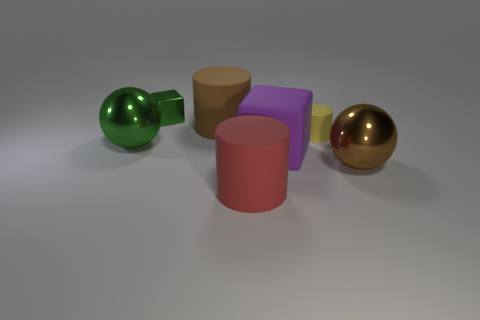Do the rubber cylinder that is right of the red thing and the big block have the same color?
Your answer should be very brief. No. There is a matte thing that is both on the right side of the brown matte object and behind the purple rubber cube; what shape is it?
Your answer should be very brief. Cylinder. The big rubber cylinder that is behind the large green metal ball is what color?
Offer a terse response. Brown. Is there anything else that has the same color as the tiny rubber thing?
Offer a terse response. No. Does the green metallic cube have the same size as the brown matte thing?
Make the answer very short. No. There is a metallic thing that is both in front of the green cube and behind the purple block; what size is it?
Your answer should be very brief. Large. How many large brown cylinders have the same material as the tiny block?
Keep it short and to the point. 0. The metal object that is the same color as the tiny block is what shape?
Your answer should be compact. Sphere. What color is the tiny metallic object?
Your response must be concise. Green. There is a brown thing that is to the right of the small rubber cylinder; does it have the same shape as the brown rubber object?
Provide a short and direct response. No. 